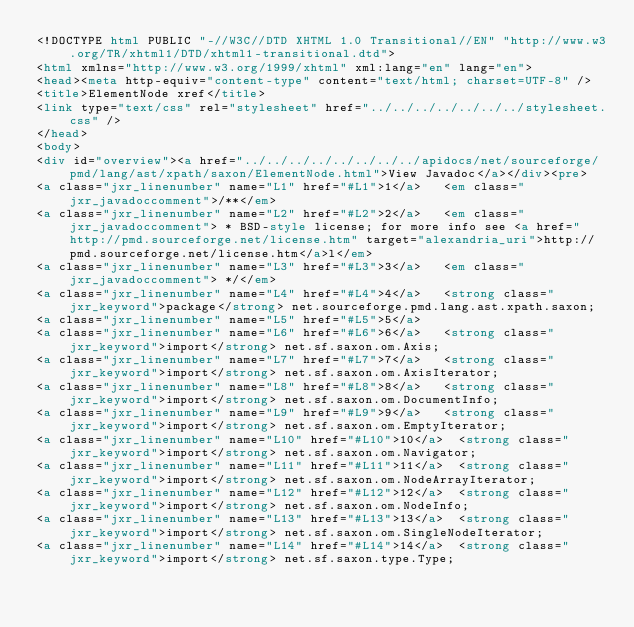<code> <loc_0><loc_0><loc_500><loc_500><_HTML_><!DOCTYPE html PUBLIC "-//W3C//DTD XHTML 1.0 Transitional//EN" "http://www.w3.org/TR/xhtml1/DTD/xhtml1-transitional.dtd">
<html xmlns="http://www.w3.org/1999/xhtml" xml:lang="en" lang="en">
<head><meta http-equiv="content-type" content="text/html; charset=UTF-8" />
<title>ElementNode xref</title>
<link type="text/css" rel="stylesheet" href="../../../../../../../stylesheet.css" />
</head>
<body>
<div id="overview"><a href="../../../../../../../../apidocs/net/sourceforge/pmd/lang/ast/xpath/saxon/ElementNode.html">View Javadoc</a></div><pre>
<a class="jxr_linenumber" name="L1" href="#L1">1</a>   <em class="jxr_javadoccomment">/**</em>
<a class="jxr_linenumber" name="L2" href="#L2">2</a>   <em class="jxr_javadoccomment"> * BSD-style license; for more info see <a href="http://pmd.sourceforge.net/license.htm" target="alexandria_uri">http://pmd.sourceforge.net/license.htm</a>l</em>
<a class="jxr_linenumber" name="L3" href="#L3">3</a>   <em class="jxr_javadoccomment"> */</em>
<a class="jxr_linenumber" name="L4" href="#L4">4</a>   <strong class="jxr_keyword">package</strong> net.sourceforge.pmd.lang.ast.xpath.saxon;
<a class="jxr_linenumber" name="L5" href="#L5">5</a>   
<a class="jxr_linenumber" name="L6" href="#L6">6</a>   <strong class="jxr_keyword">import</strong> net.sf.saxon.om.Axis;
<a class="jxr_linenumber" name="L7" href="#L7">7</a>   <strong class="jxr_keyword">import</strong> net.sf.saxon.om.AxisIterator;
<a class="jxr_linenumber" name="L8" href="#L8">8</a>   <strong class="jxr_keyword">import</strong> net.sf.saxon.om.DocumentInfo;
<a class="jxr_linenumber" name="L9" href="#L9">9</a>   <strong class="jxr_keyword">import</strong> net.sf.saxon.om.EmptyIterator;
<a class="jxr_linenumber" name="L10" href="#L10">10</a>  <strong class="jxr_keyword">import</strong> net.sf.saxon.om.Navigator;
<a class="jxr_linenumber" name="L11" href="#L11">11</a>  <strong class="jxr_keyword">import</strong> net.sf.saxon.om.NodeArrayIterator;
<a class="jxr_linenumber" name="L12" href="#L12">12</a>  <strong class="jxr_keyword">import</strong> net.sf.saxon.om.NodeInfo;
<a class="jxr_linenumber" name="L13" href="#L13">13</a>  <strong class="jxr_keyword">import</strong> net.sf.saxon.om.SingleNodeIterator;
<a class="jxr_linenumber" name="L14" href="#L14">14</a>  <strong class="jxr_keyword">import</strong> net.sf.saxon.type.Type;</code> 